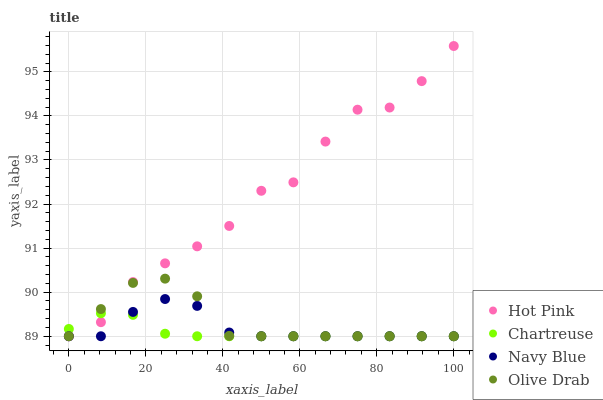Does Chartreuse have the minimum area under the curve?
Answer yes or no. Yes. Does Hot Pink have the maximum area under the curve?
Answer yes or no. Yes. Does Hot Pink have the minimum area under the curve?
Answer yes or no. No. Does Chartreuse have the maximum area under the curve?
Answer yes or no. No. Is Chartreuse the smoothest?
Answer yes or no. Yes. Is Hot Pink the roughest?
Answer yes or no. Yes. Is Hot Pink the smoothest?
Answer yes or no. No. Is Chartreuse the roughest?
Answer yes or no. No. Does Navy Blue have the lowest value?
Answer yes or no. Yes. Does Hot Pink have the highest value?
Answer yes or no. Yes. Does Chartreuse have the highest value?
Answer yes or no. No. Does Chartreuse intersect Hot Pink?
Answer yes or no. Yes. Is Chartreuse less than Hot Pink?
Answer yes or no. No. Is Chartreuse greater than Hot Pink?
Answer yes or no. No. 